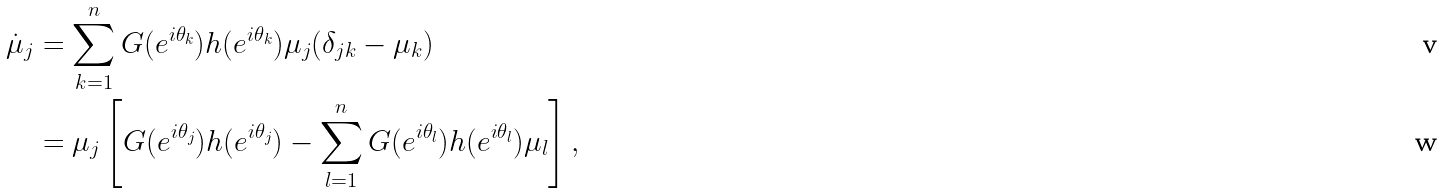Convert formula to latex. <formula><loc_0><loc_0><loc_500><loc_500>\dot { \mu } _ { j } & = \sum _ { k = 1 } ^ { n } G ( e ^ { i \theta _ { k } } ) h ( e ^ { i \theta _ { k } } ) \mu _ { j } ( \delta _ { j k } - \mu _ { k } ) \\ & = \mu _ { j } \left [ G ( e ^ { i \theta _ { j } } ) h ( e ^ { i \theta _ { j } } ) - \sum _ { l = 1 } ^ { n } G ( e ^ { i \theta _ { l } } ) h ( e ^ { i \theta _ { l } } ) \mu _ { l } \right ] ,</formula> 